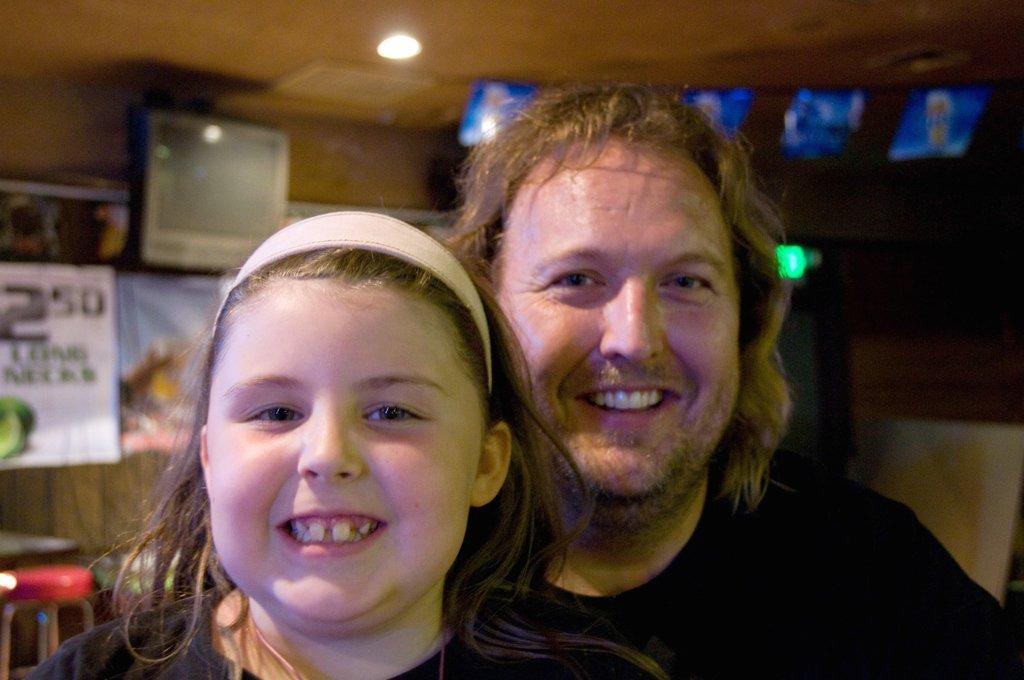Can you describe this image briefly? In this image, in the middle, we can see two people man and a girl wearing black color dress. In the background, we can see a television, some posters which are attached to a wall, table, chairs. At the top, we can see a roof with few lights. 